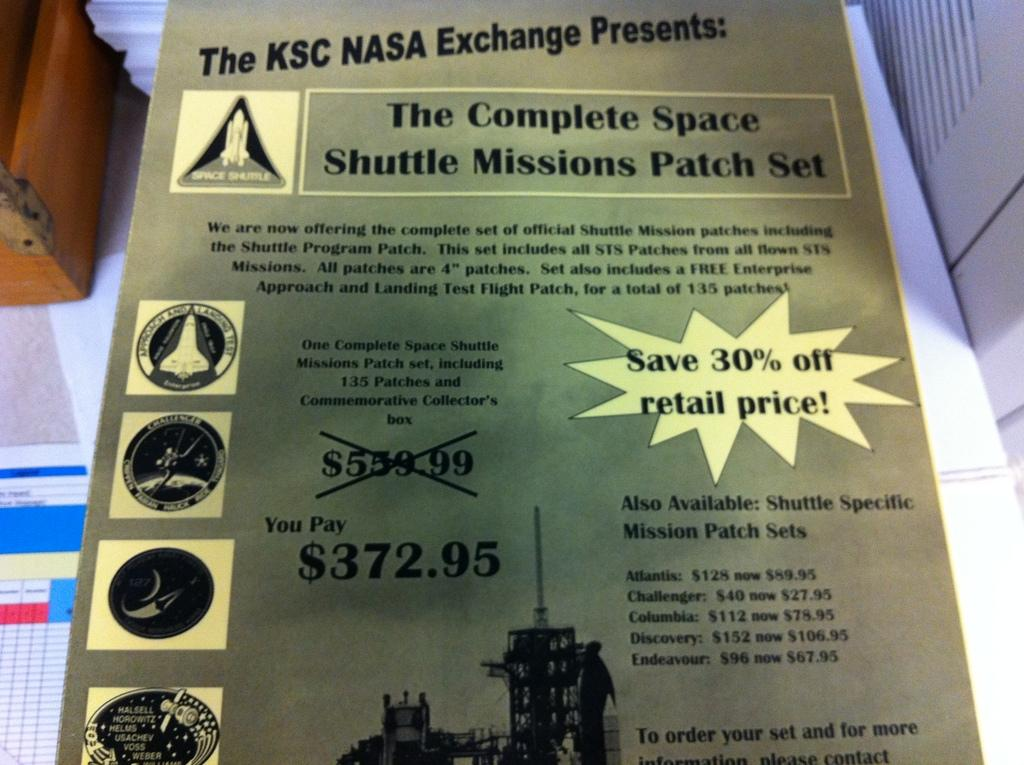<image>
Present a compact description of the photo's key features. a flyer advertising 30% off retail price patches 